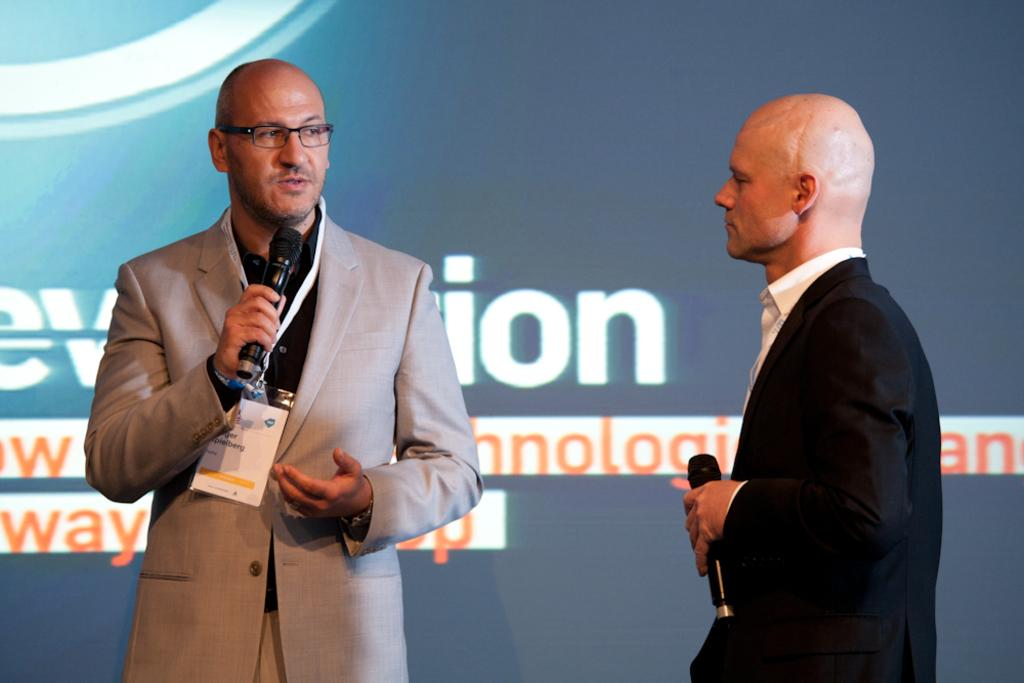How many people are in the image? There are two persons in the image. What are the persons doing in the image? The persons are standing and holding microphones. What can be seen in the background of the image? There is a screen in the background of the image. What type of hot burst can be seen coming from the microphones in the image? There is no hot burst present in the image; the persons are simply holding microphones. 